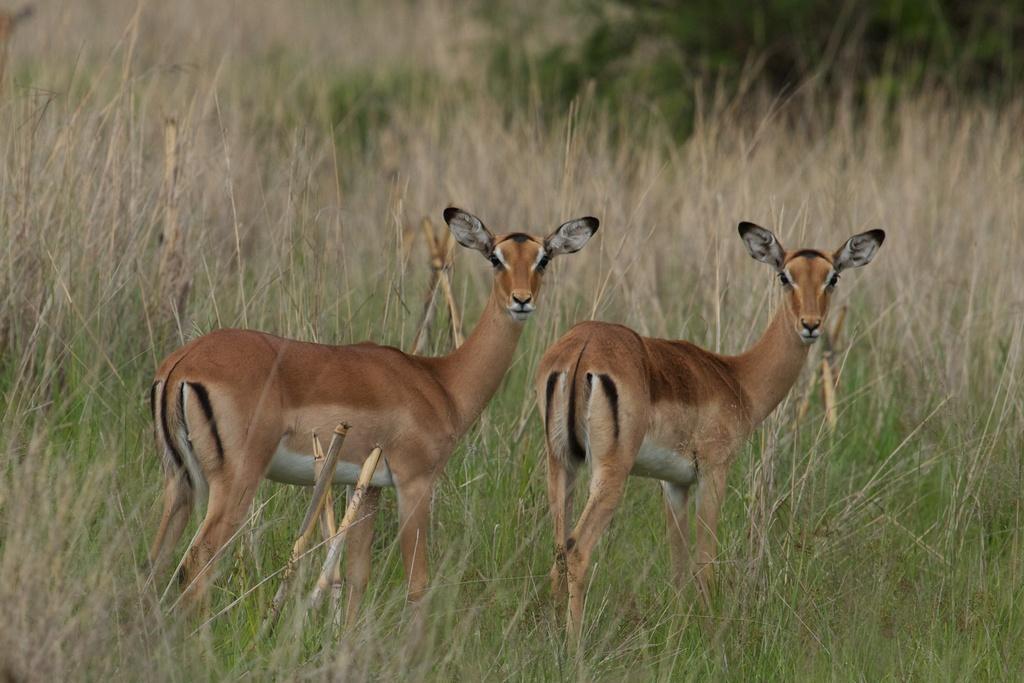In one or two sentences, can you explain what this image depicts? In this image I can see the gazelle. In the background, I can see the grass. 